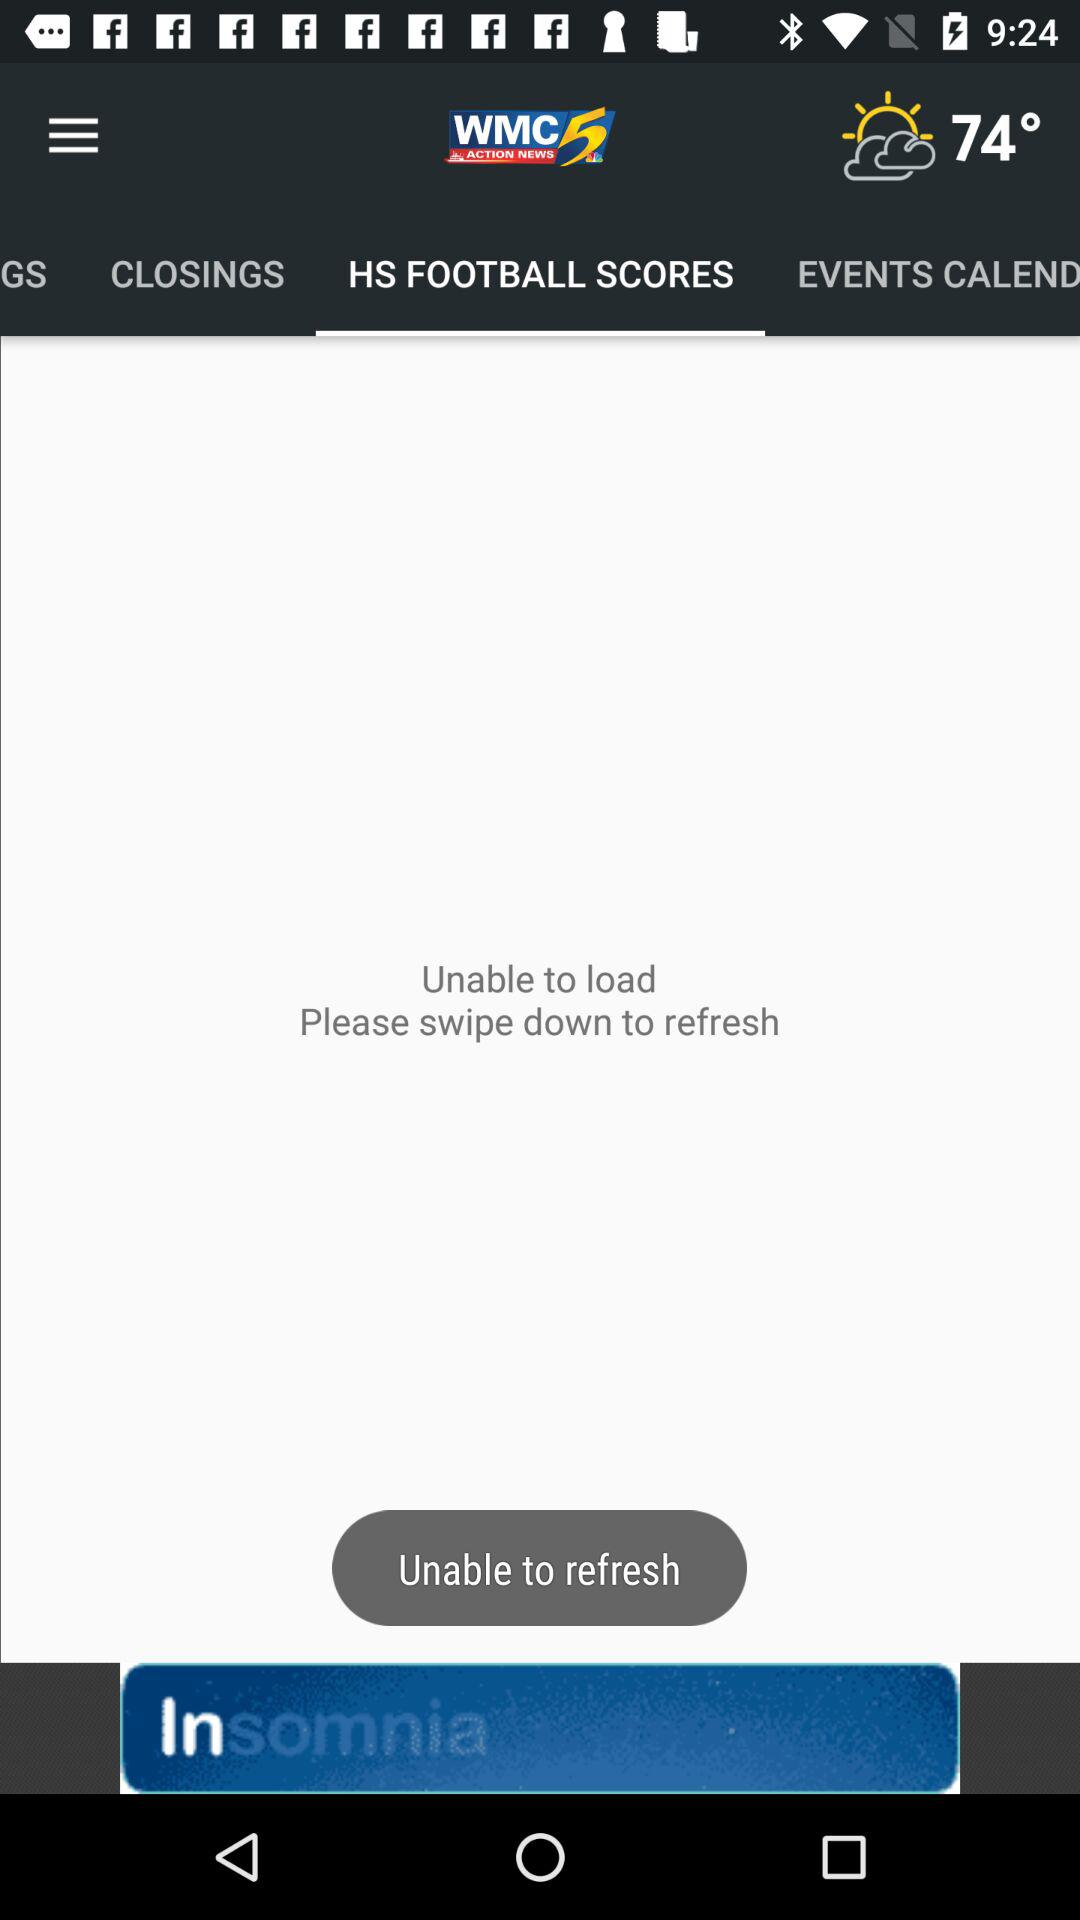What is the name of the application? The name of the application is "WMC ACTION NEWS 5". 